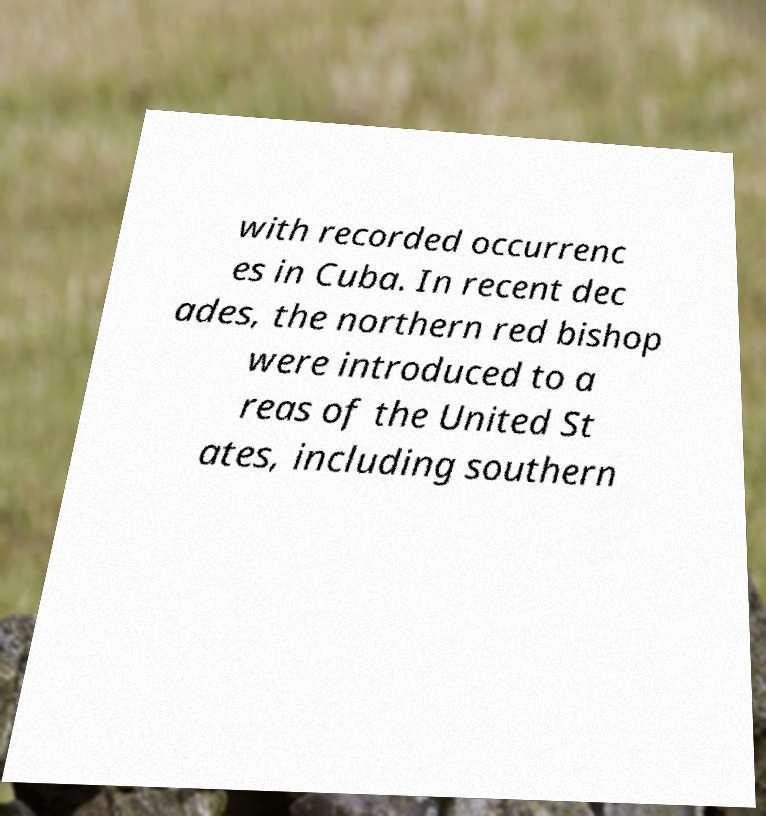Could you extract and type out the text from this image? with recorded occurrenc es in Cuba. In recent dec ades, the northern red bishop were introduced to a reas of the United St ates, including southern 